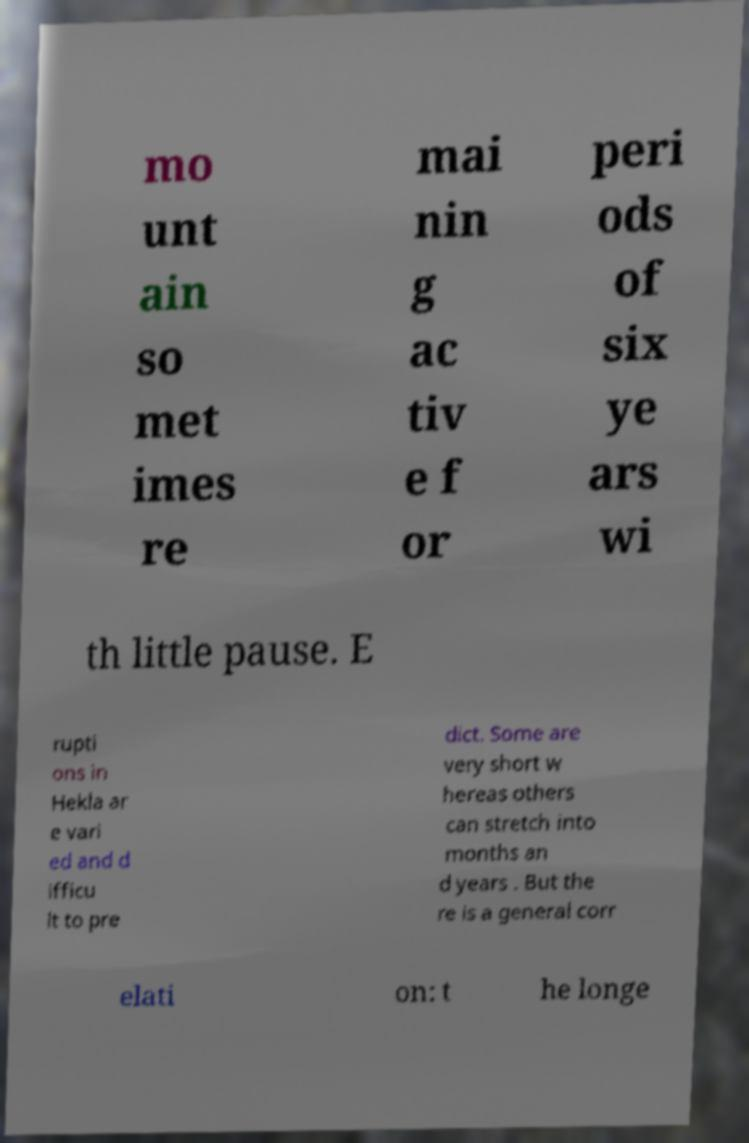Could you assist in decoding the text presented in this image and type it out clearly? mo unt ain so met imes re mai nin g ac tiv e f or peri ods of six ye ars wi th little pause. E rupti ons in Hekla ar e vari ed and d ifficu lt to pre dict. Some are very short w hereas others can stretch into months an d years . But the re is a general corr elati on: t he longe 